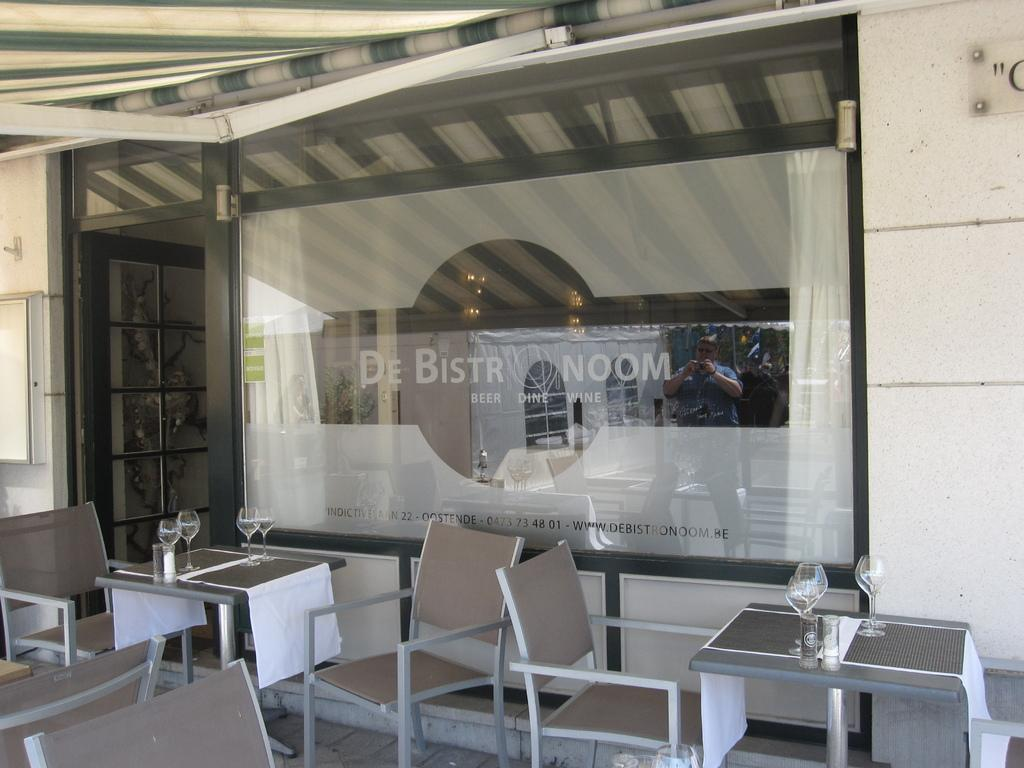<image>
Offer a succinct explanation of the picture presented. The outside of a restaurant with the sign beer, dine, and wine on the window. 